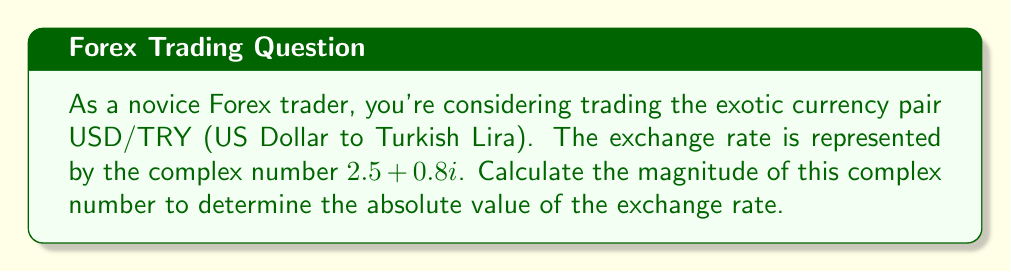Help me with this question. To calculate the magnitude of a complex number, we use the formula:

$$|a + bi| = \sqrt{a^2 + b^2}$$

Where $a$ is the real part and $b$ is the imaginary part of the complex number.

Given the complex number $2.5 + 0.8i$:
$a = 2.5$
$b = 0.8$

Let's substitute these values into the formula:

$$|2.5 + 0.8i| = \sqrt{2.5^2 + 0.8^2}$$

Now, let's calculate step by step:

1. Calculate $2.5^2$:
   $2.5^2 = 6.25$

2. Calculate $0.8^2$:
   $0.8^2 = 0.64$

3. Add the results from steps 1 and 2:
   $6.25 + 0.64 = 6.89$

4. Calculate the square root of the sum:
   $\sqrt{6.89} \approx 2.6248$

Therefore, the magnitude of the complex number $2.5 + 0.8i$ is approximately 2.6248.

In the context of Forex trading, this means the absolute value of the USD/TRY exchange rate is about 2.6248, regardless of market fluctuations represented by the imaginary component.
Answer: $2.6248$ 